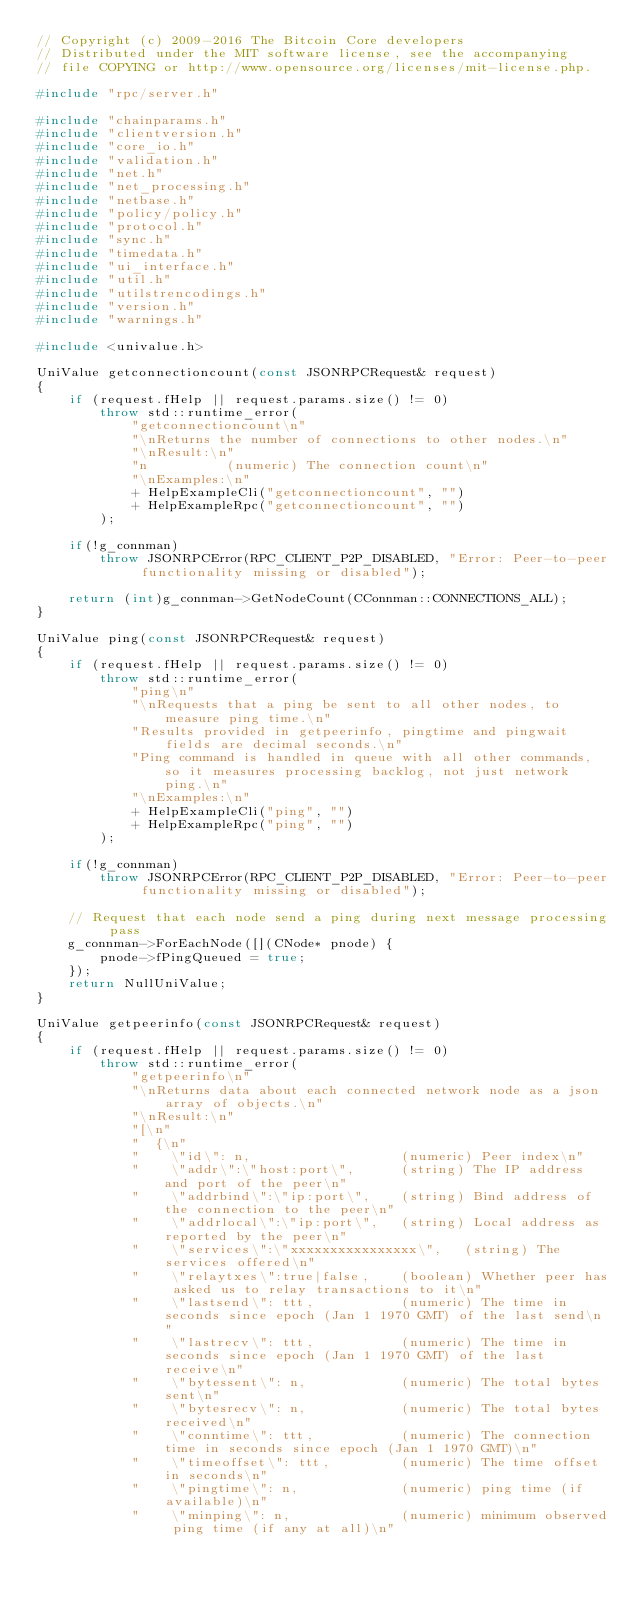<code> <loc_0><loc_0><loc_500><loc_500><_C++_>// Copyright (c) 2009-2016 The Bitcoin Core developers
// Distributed under the MIT software license, see the accompanying
// file COPYING or http://www.opensource.org/licenses/mit-license.php.

#include "rpc/server.h"

#include "chainparams.h"
#include "clientversion.h"
#include "core_io.h"
#include "validation.h"
#include "net.h"
#include "net_processing.h"
#include "netbase.h"
#include "policy/policy.h"
#include "protocol.h"
#include "sync.h"
#include "timedata.h"
#include "ui_interface.h"
#include "util.h"
#include "utilstrencodings.h"
#include "version.h"
#include "warnings.h"

#include <univalue.h>

UniValue getconnectioncount(const JSONRPCRequest& request)
{
    if (request.fHelp || request.params.size() != 0)
        throw std::runtime_error(
            "getconnectioncount\n"
            "\nReturns the number of connections to other nodes.\n"
            "\nResult:\n"
            "n          (numeric) The connection count\n"
            "\nExamples:\n"
            + HelpExampleCli("getconnectioncount", "")
            + HelpExampleRpc("getconnectioncount", "")
        );

    if(!g_connman)
        throw JSONRPCError(RPC_CLIENT_P2P_DISABLED, "Error: Peer-to-peer functionality missing or disabled");

    return (int)g_connman->GetNodeCount(CConnman::CONNECTIONS_ALL);
}

UniValue ping(const JSONRPCRequest& request)
{
    if (request.fHelp || request.params.size() != 0)
        throw std::runtime_error(
            "ping\n"
            "\nRequests that a ping be sent to all other nodes, to measure ping time.\n"
            "Results provided in getpeerinfo, pingtime and pingwait fields are decimal seconds.\n"
            "Ping command is handled in queue with all other commands, so it measures processing backlog, not just network ping.\n"
            "\nExamples:\n"
            + HelpExampleCli("ping", "")
            + HelpExampleRpc("ping", "")
        );

    if(!g_connman)
        throw JSONRPCError(RPC_CLIENT_P2P_DISABLED, "Error: Peer-to-peer functionality missing or disabled");

    // Request that each node send a ping during next message processing pass
    g_connman->ForEachNode([](CNode* pnode) {
        pnode->fPingQueued = true;
    });
    return NullUniValue;
}

UniValue getpeerinfo(const JSONRPCRequest& request)
{
    if (request.fHelp || request.params.size() != 0)
        throw std::runtime_error(
            "getpeerinfo\n"
            "\nReturns data about each connected network node as a json array of objects.\n"
            "\nResult:\n"
            "[\n"
            "  {\n"
            "    \"id\": n,                   (numeric) Peer index\n"
            "    \"addr\":\"host:port\",      (string) The IP address and port of the peer\n"
            "    \"addrbind\":\"ip:port\",    (string) Bind address of the connection to the peer\n"
            "    \"addrlocal\":\"ip:port\",   (string) Local address as reported by the peer\n"
            "    \"services\":\"xxxxxxxxxxxxxxxx\",   (string) The services offered\n"
            "    \"relaytxes\":true|false,    (boolean) Whether peer has asked us to relay transactions to it\n"
            "    \"lastsend\": ttt,           (numeric) The time in seconds since epoch (Jan 1 1970 GMT) of the last send\n"
            "    \"lastrecv\": ttt,           (numeric) The time in seconds since epoch (Jan 1 1970 GMT) of the last receive\n"
            "    \"bytessent\": n,            (numeric) The total bytes sent\n"
            "    \"bytesrecv\": n,            (numeric) The total bytes received\n"
            "    \"conntime\": ttt,           (numeric) The connection time in seconds since epoch (Jan 1 1970 GMT)\n"
            "    \"timeoffset\": ttt,         (numeric) The time offset in seconds\n"
            "    \"pingtime\": n,             (numeric) ping time (if available)\n"
            "    \"minping\": n,              (numeric) minimum observed ping time (if any at all)\n"</code> 